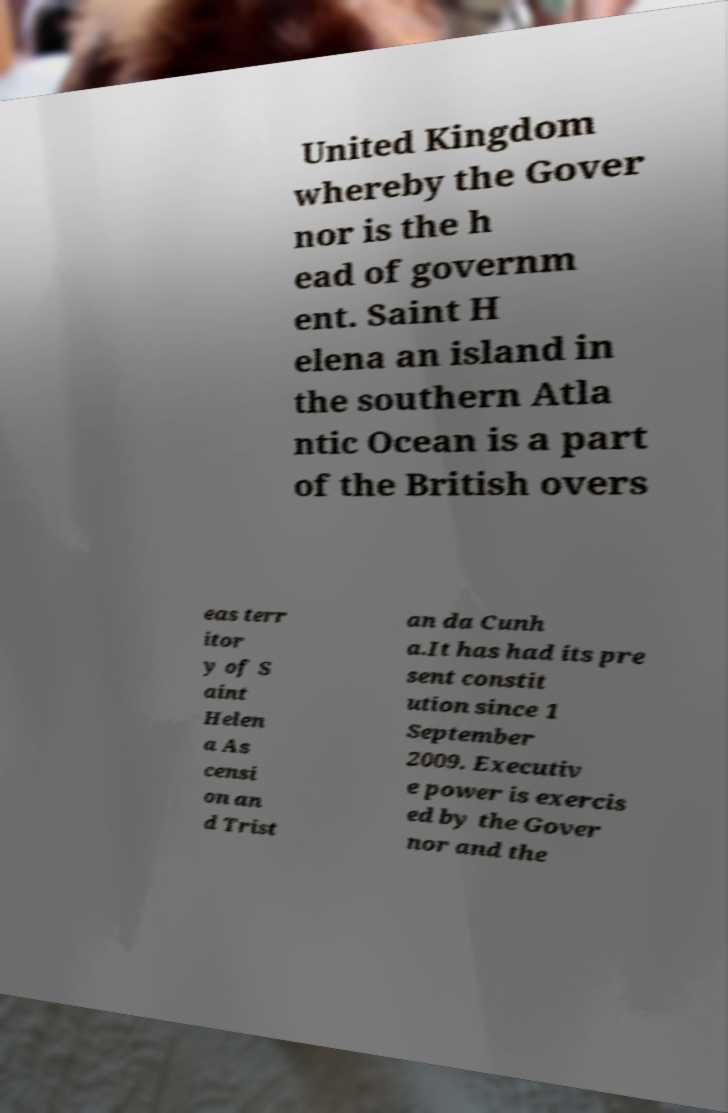There's text embedded in this image that I need extracted. Can you transcribe it verbatim? United Kingdom whereby the Gover nor is the h ead of governm ent. Saint H elena an island in the southern Atla ntic Ocean is a part of the British overs eas terr itor y of S aint Helen a As censi on an d Trist an da Cunh a.It has had its pre sent constit ution since 1 September 2009. Executiv e power is exercis ed by the Gover nor and the 